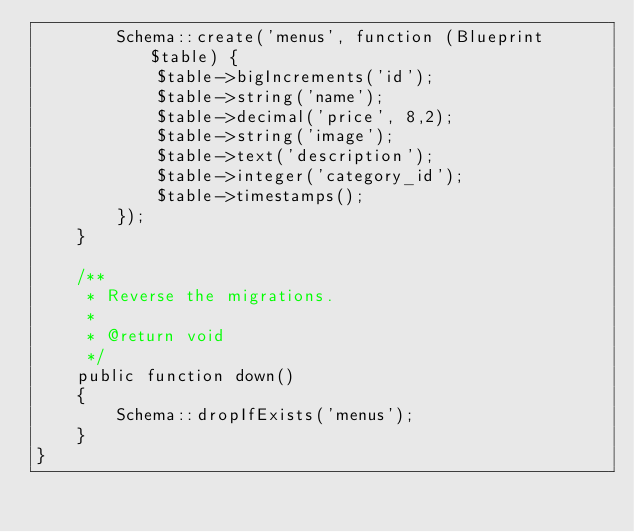Convert code to text. <code><loc_0><loc_0><loc_500><loc_500><_PHP_>        Schema::create('menus', function (Blueprint $table) {
            $table->bigIncrements('id');
            $table->string('name');
            $table->decimal('price', 8,2);
            $table->string('image');
            $table->text('description');
            $table->integer('category_id');
            $table->timestamps();
        });
    }

    /**
     * Reverse the migrations.
     *
     * @return void
     */
    public function down()
    {
        Schema::dropIfExists('menus');
    }
}
</code> 